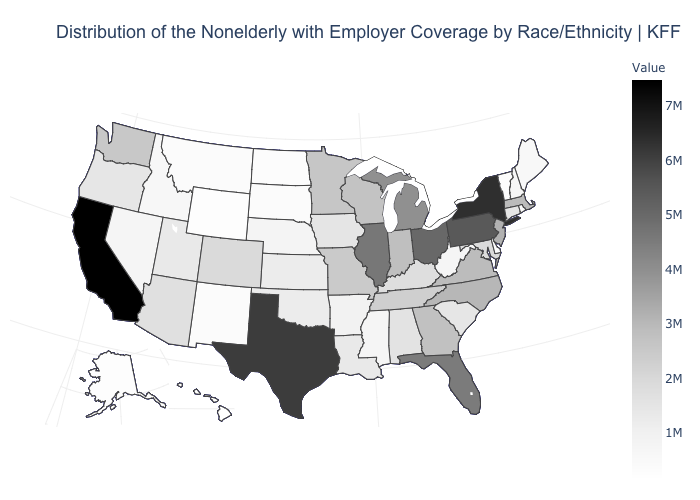Which states hav the highest value in the South?
Write a very short answer. Texas. Does Colorado have the highest value in the West?
Answer briefly. No. Is the legend a continuous bar?
Give a very brief answer. Yes. Which states hav the highest value in the South?
Short answer required. Texas. 